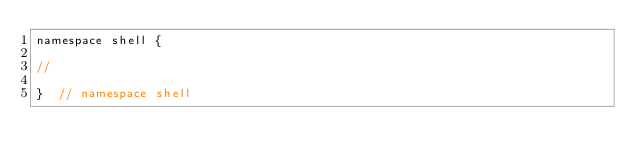<code> <loc_0><loc_0><loc_500><loc_500><_C++_>namespace shell {

//

}  // namespace shell
</code> 